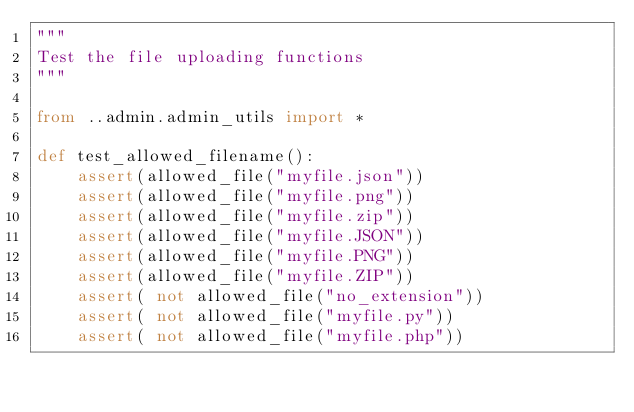Convert code to text. <code><loc_0><loc_0><loc_500><loc_500><_Python_>"""
Test the file uploading functions
"""

from ..admin.admin_utils import *

def test_allowed_filename():
    assert(allowed_file("myfile.json"))
    assert(allowed_file("myfile.png"))
    assert(allowed_file("myfile.zip"))
    assert(allowed_file("myfile.JSON"))
    assert(allowed_file("myfile.PNG"))
    assert(allowed_file("myfile.ZIP"))
    assert( not allowed_file("no_extension"))
    assert( not allowed_file("myfile.py"))
    assert( not allowed_file("myfile.php"))
</code> 